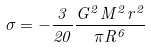Convert formula to latex. <formula><loc_0><loc_0><loc_500><loc_500>\sigma = - \frac { 3 } { 2 0 } \frac { G ^ { 2 } M ^ { 2 } r ^ { 2 } } { \pi R ^ { 6 } }</formula> 